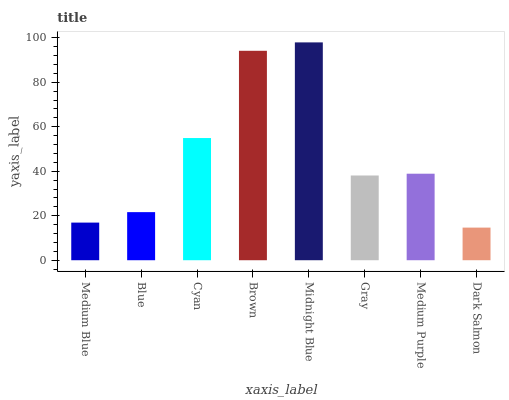Is Dark Salmon the minimum?
Answer yes or no. Yes. Is Midnight Blue the maximum?
Answer yes or no. Yes. Is Blue the minimum?
Answer yes or no. No. Is Blue the maximum?
Answer yes or no. No. Is Blue greater than Medium Blue?
Answer yes or no. Yes. Is Medium Blue less than Blue?
Answer yes or no. Yes. Is Medium Blue greater than Blue?
Answer yes or no. No. Is Blue less than Medium Blue?
Answer yes or no. No. Is Medium Purple the high median?
Answer yes or no. Yes. Is Gray the low median?
Answer yes or no. Yes. Is Dark Salmon the high median?
Answer yes or no. No. Is Blue the low median?
Answer yes or no. No. 